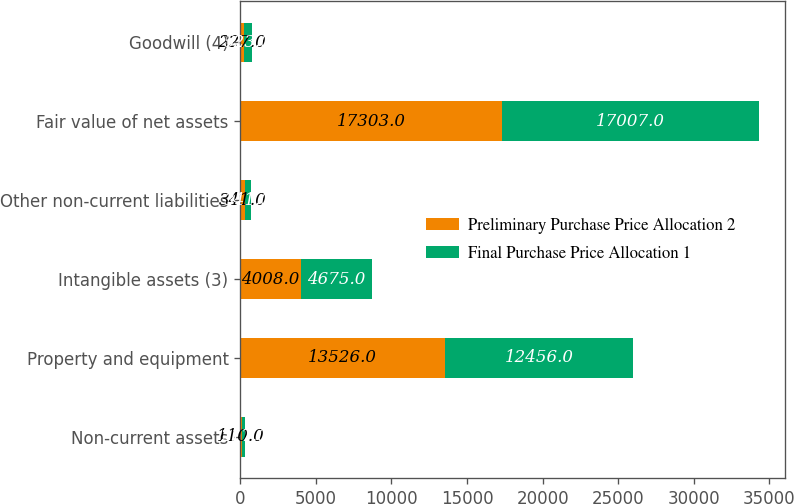<chart> <loc_0><loc_0><loc_500><loc_500><stacked_bar_chart><ecel><fcel>Non-current assets<fcel>Property and equipment<fcel>Intangible assets (3)<fcel>Other non-current liabilities<fcel>Fair value of net assets<fcel>Goodwill (4)<nl><fcel>Preliminary Purchase Price Allocation 2<fcel>110<fcel>13526<fcel>4008<fcel>341<fcel>17303<fcel>227<nl><fcel>Final Purchase Price Allocation 1<fcel>217<fcel>12456<fcel>4675<fcel>341<fcel>17007<fcel>523<nl></chart> 